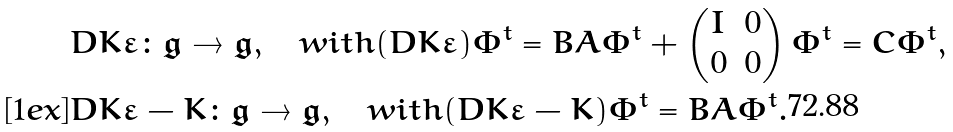<formula> <loc_0><loc_0><loc_500><loc_500>& D K \varepsilon \colon \mathfrak g \to \mathfrak g , \quad w i t h ( D K \varepsilon ) \Phi ^ { t } = B A \Phi ^ { t } + \begin{pmatrix} I & 0 \\ 0 & 0 \end{pmatrix} \Phi ^ { t } = C \Phi ^ { t } , \\ [ 1 e x ] & D K \varepsilon - K \colon \mathfrak g \to \mathfrak g , \quad w i t h ( D K \varepsilon - K ) \Phi ^ { t } = B A \Phi ^ { t } .</formula> 